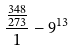<formula> <loc_0><loc_0><loc_500><loc_500>\frac { \frac { 3 4 8 } { 2 7 3 } } { 1 } - 9 ^ { 1 3 }</formula> 